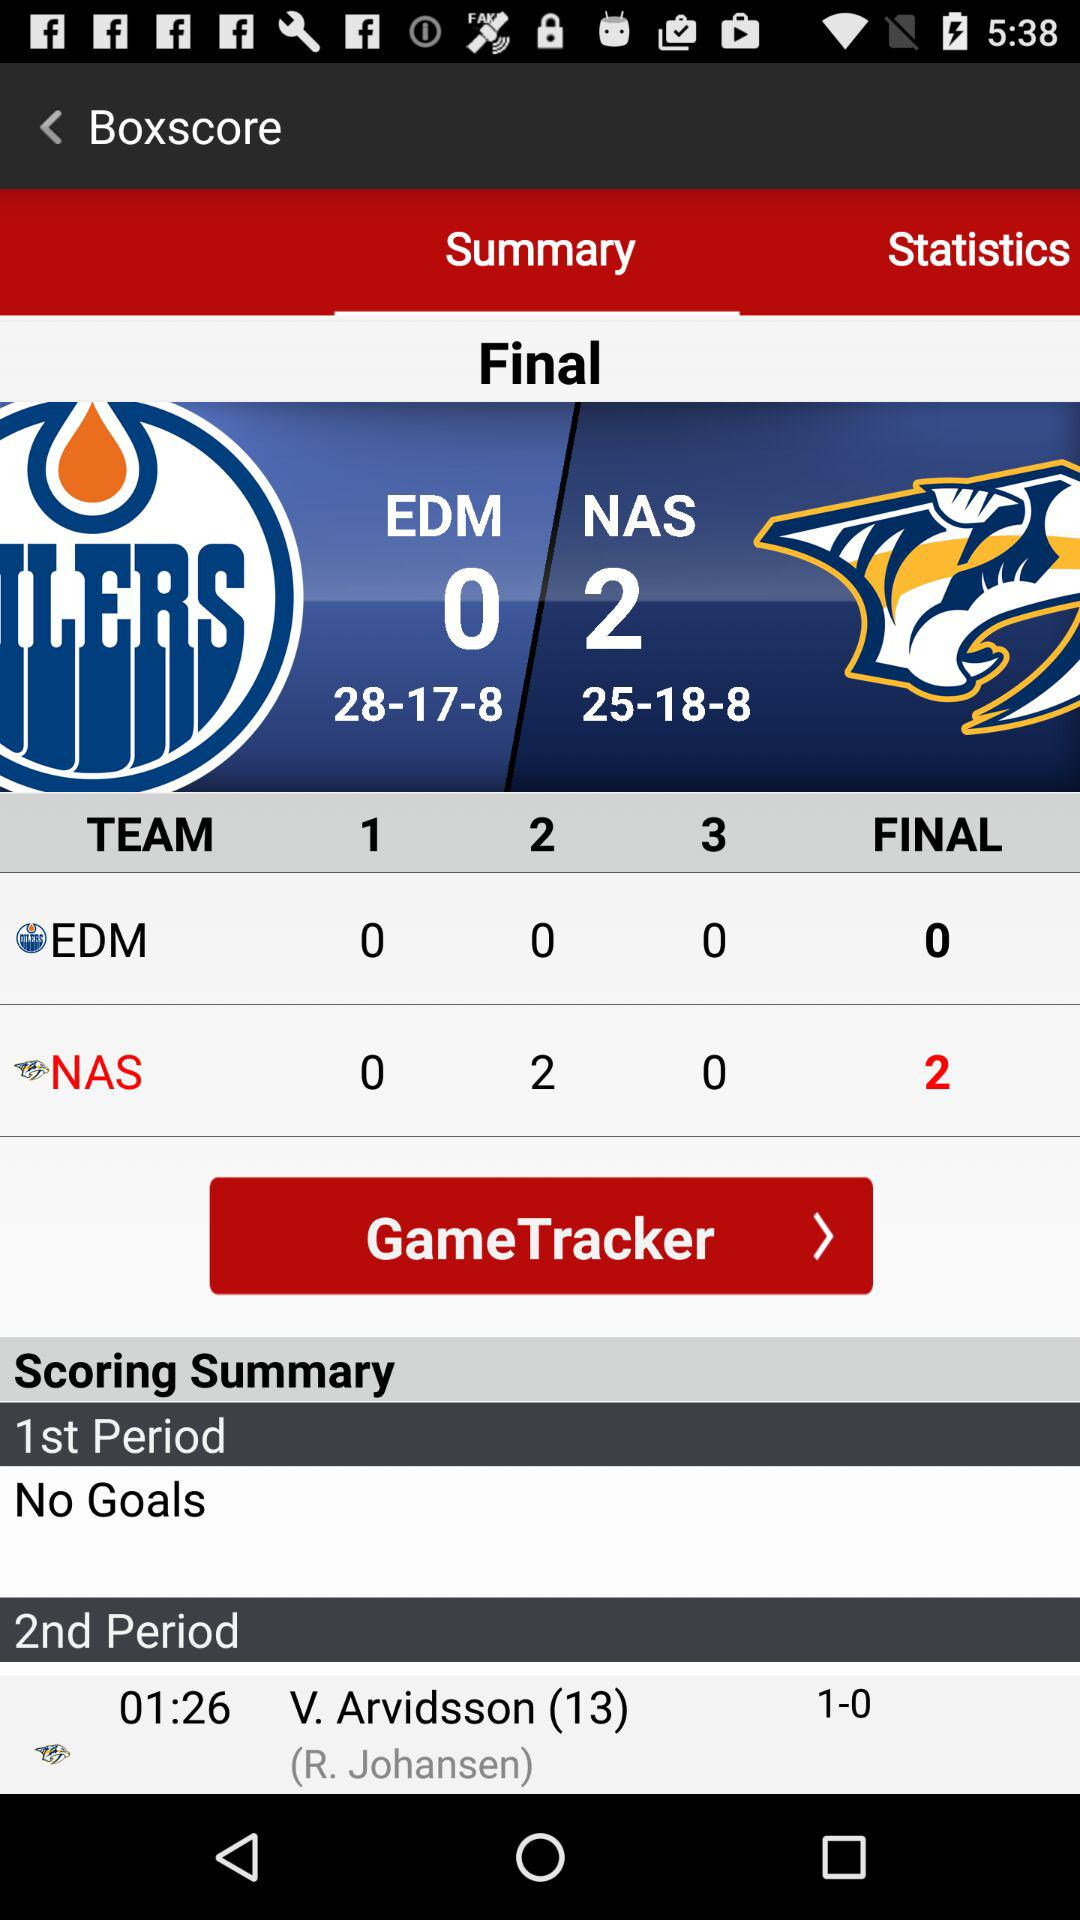What is the final score of the team NAS? The final score of the team NAS is 2. 